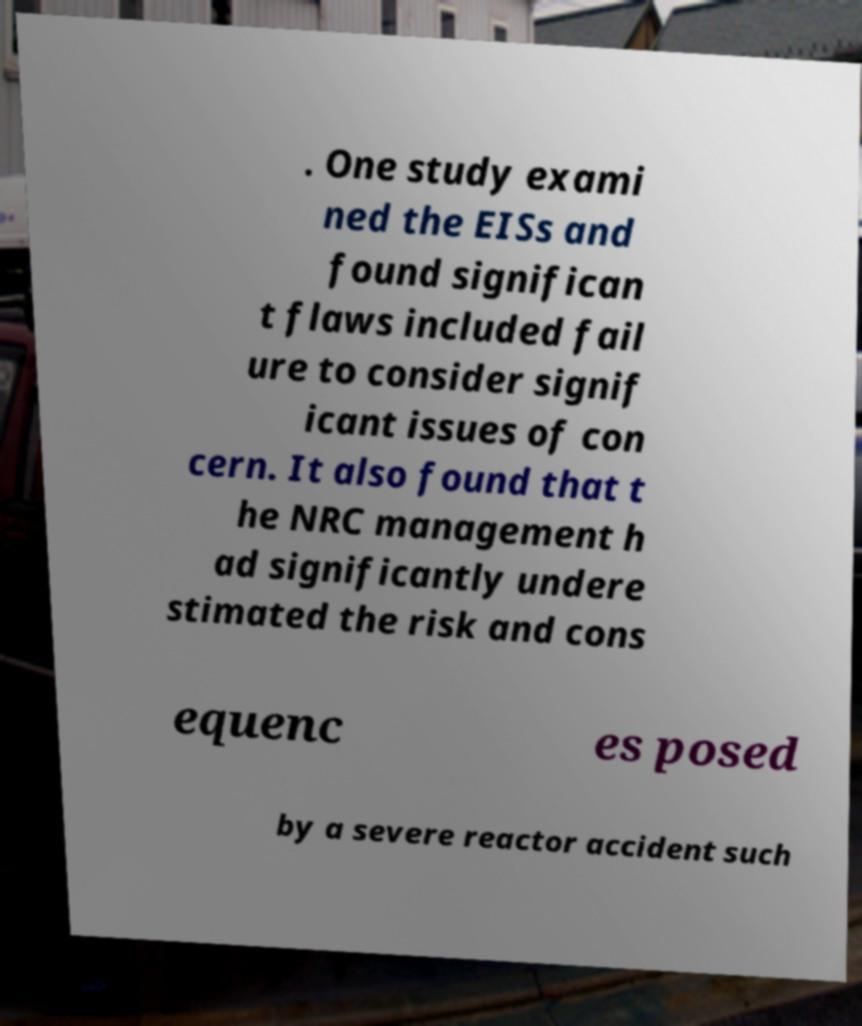What messages or text are displayed in this image? I need them in a readable, typed format. . One study exami ned the EISs and found significan t flaws included fail ure to consider signif icant issues of con cern. It also found that t he NRC management h ad significantly undere stimated the risk and cons equenc es posed by a severe reactor accident such 